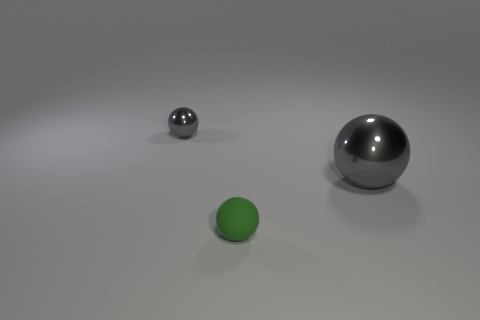What number of shiny things are behind the large ball and in front of the small metal sphere? 0 